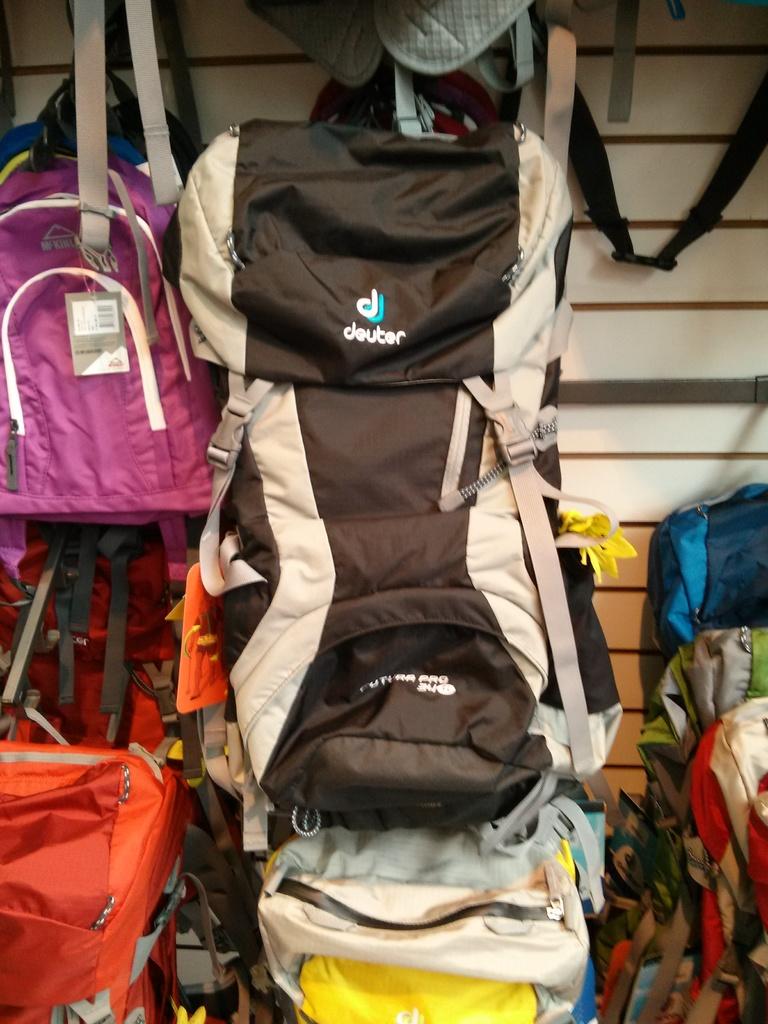What brand of bag is this?
Give a very brief answer. Deuter. 